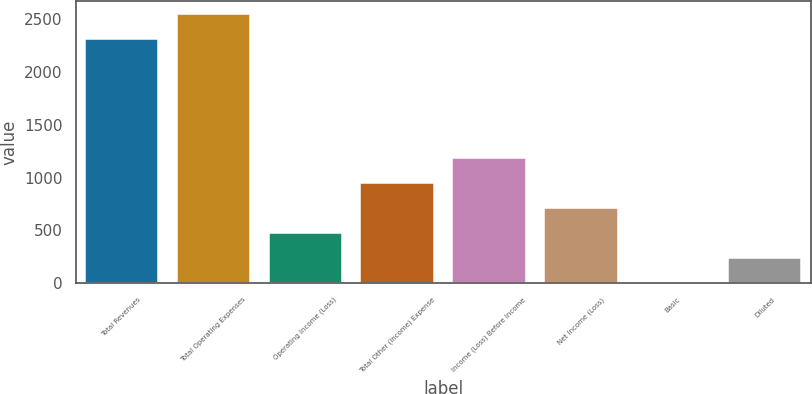<chart> <loc_0><loc_0><loc_500><loc_500><bar_chart><fcel>Total Revenues<fcel>Total Operating Expenses<fcel>Operating Income (Loss)<fcel>Total Other (Income) Expense<fcel>Income (Loss) Before Income<fcel>Net Income (Loss)<fcel>Basic<fcel>Diluted<nl><fcel>2313<fcel>2550.03<fcel>474.81<fcel>948.87<fcel>1185.89<fcel>711.84<fcel>0.75<fcel>237.78<nl></chart> 